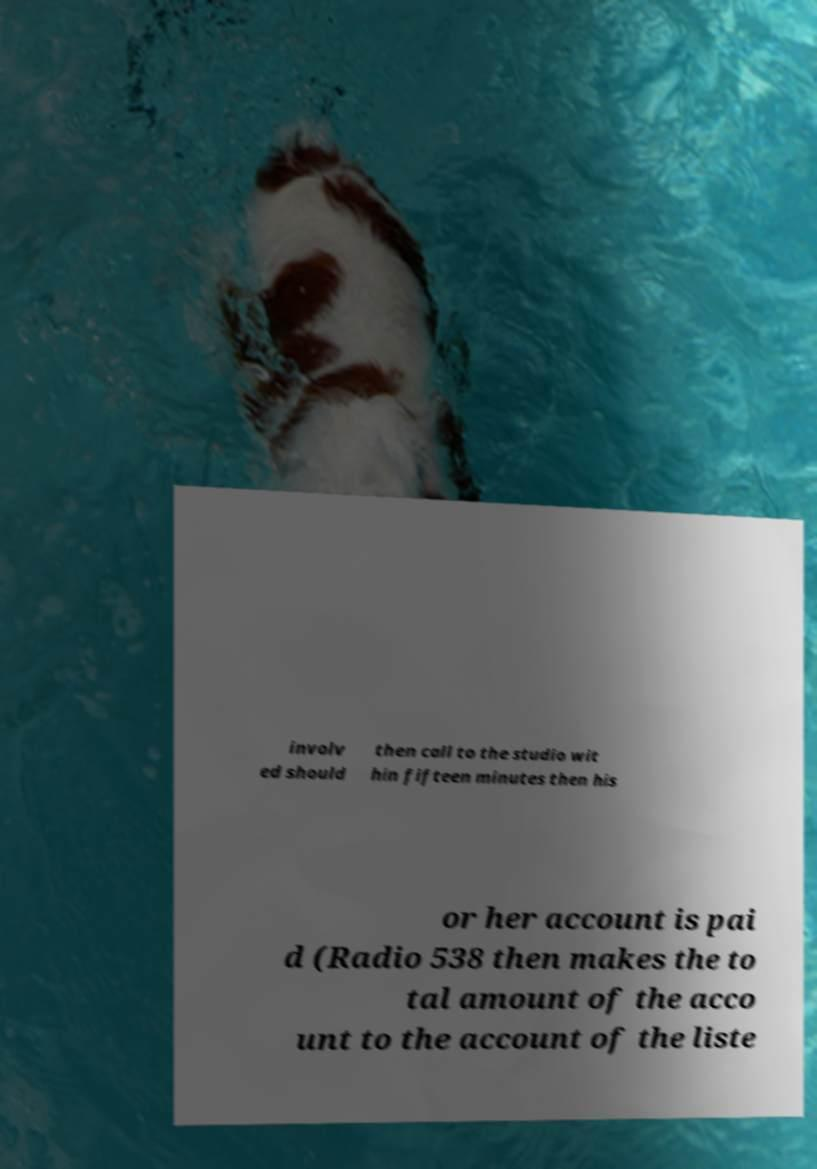Can you read and provide the text displayed in the image?This photo seems to have some interesting text. Can you extract and type it out for me? involv ed should then call to the studio wit hin fifteen minutes then his or her account is pai d (Radio 538 then makes the to tal amount of the acco unt to the account of the liste 